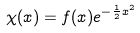<formula> <loc_0><loc_0><loc_500><loc_500>\chi ( x ) = f ( x ) e ^ { - \frac { 1 } { 2 } x ^ { 2 } }</formula> 